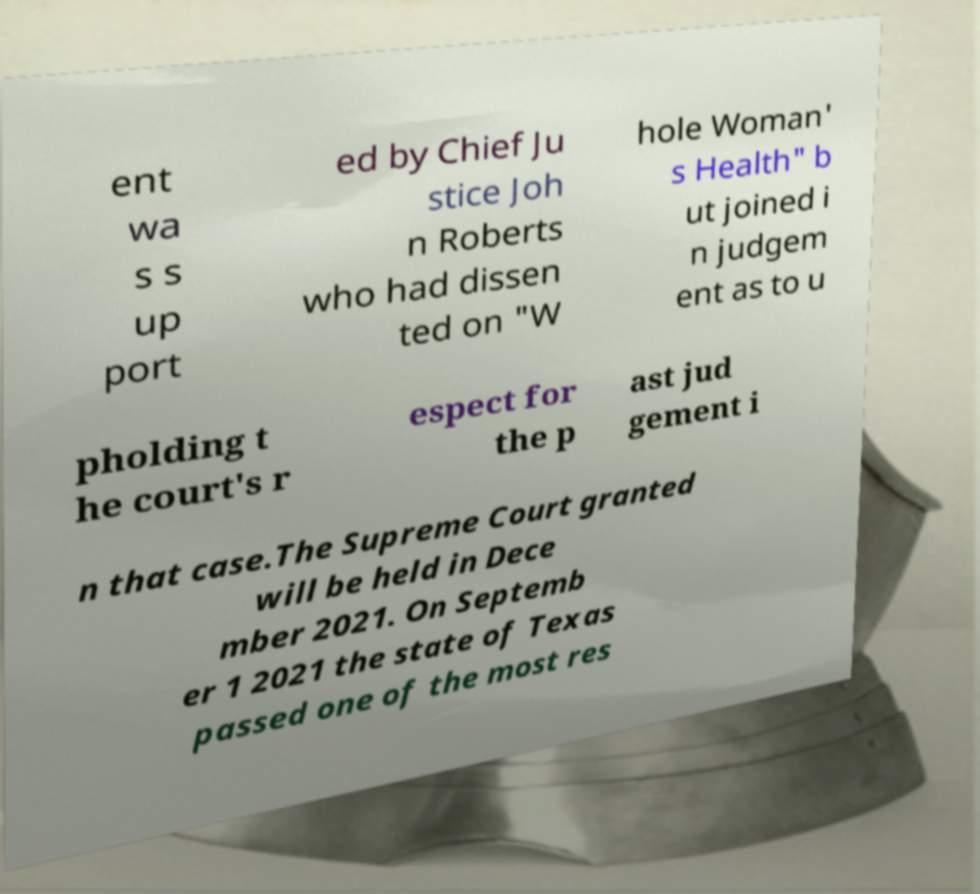Can you read and provide the text displayed in the image?This photo seems to have some interesting text. Can you extract and type it out for me? ent wa s s up port ed by Chief Ju stice Joh n Roberts who had dissen ted on "W hole Woman' s Health" b ut joined i n judgem ent as to u pholding t he court's r espect for the p ast jud gement i n that case.The Supreme Court granted will be held in Dece mber 2021. On Septemb er 1 2021 the state of Texas passed one of the most res 